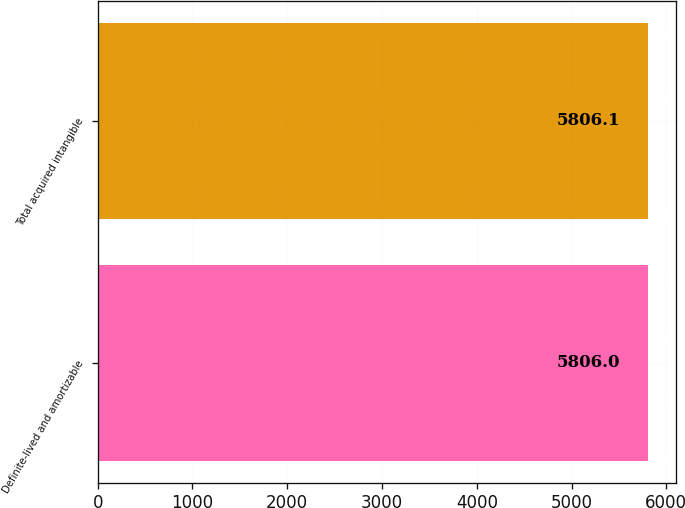Convert chart. <chart><loc_0><loc_0><loc_500><loc_500><bar_chart><fcel>Definite-lived and amortizable<fcel>Total acquired intangible<nl><fcel>5806<fcel>5806.1<nl></chart> 